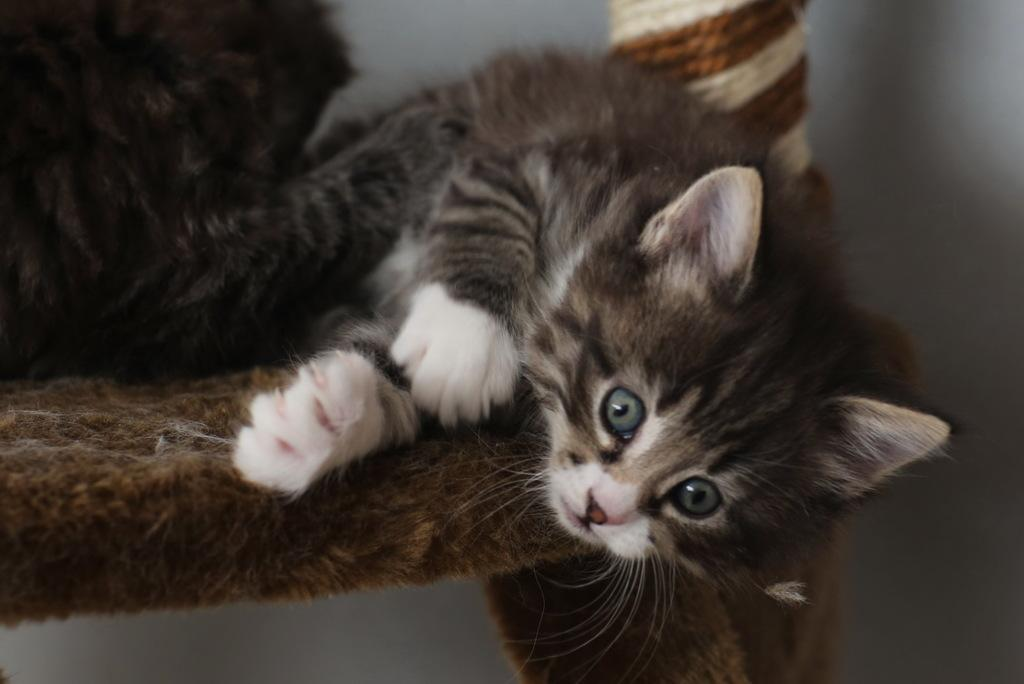What is the main subject of the image? There are two cats in the image. Can you describe the position of the cats? One cat is lying on a platform, and there is another cat beside it. What else can be seen in the image? There is a pole in the image. What is visible in the background of the image? There is a wall visible in the background of the image. Reasoning: Let' Let's think step by step in order to produce the conversation. We start by identifying the main subjects in the image, which are the two cats. Then, we describe their positions and actions, noting that one cat is lying on a platform and the other is beside it. Next, we mention the presence of a pole as an additional object in the image. Finally, we describe the background, which includes a wall. Each question is designed to elicit a specific detail about the image that is known from the provided facts. Absurd Question/Answer: What type of waves can be seen in the image? There are no waves present in the image; it features two cats, a platform, a pole, and a wall. Can you tell me how the cats are touching each other in the image? There is no indication of the cats touching each other in the image. --- Facts: 1. There is a person holding a book in the image. 2. The person is sitting on a chair. 3. There is a table in front of the person. 4. The table has a lamp on it. 5. The background of the image is a room with a window. Absurd Topics: rain, dance, elephant Conversation: What is the person in the image doing? The person is holding a book in the image. Can you describe the person's position? The person is sitting on a chair. What is on the table in front of the person? There is a lamp on the table. What can be seen in the background of the image? The background of the image is a room with a window. Reasoning: Let's think step by step in order to produce the conversation. We start by identifying the main subject in the image, which is the person holding a book. Then, we describe the person's position and actions, noting that they are sitting on a 